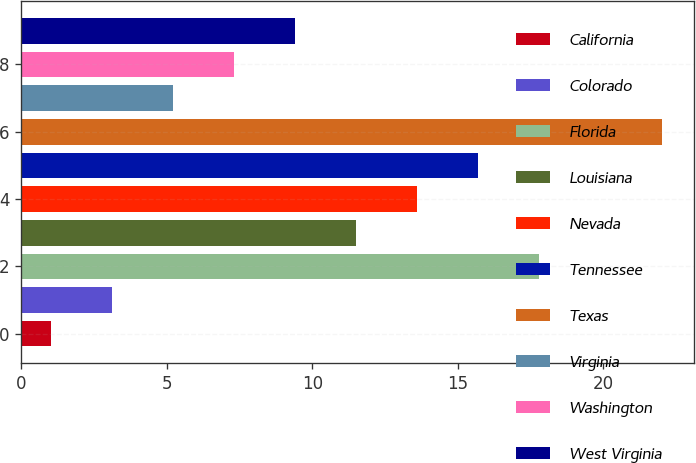Convert chart. <chart><loc_0><loc_0><loc_500><loc_500><bar_chart><fcel>California<fcel>Colorado<fcel>Florida<fcel>Louisiana<fcel>Nevada<fcel>Tennessee<fcel>Texas<fcel>Virginia<fcel>Washington<fcel>West Virginia<nl><fcel>1<fcel>3.1<fcel>17.8<fcel>11.5<fcel>13.6<fcel>15.7<fcel>22<fcel>5.2<fcel>7.3<fcel>9.4<nl></chart> 